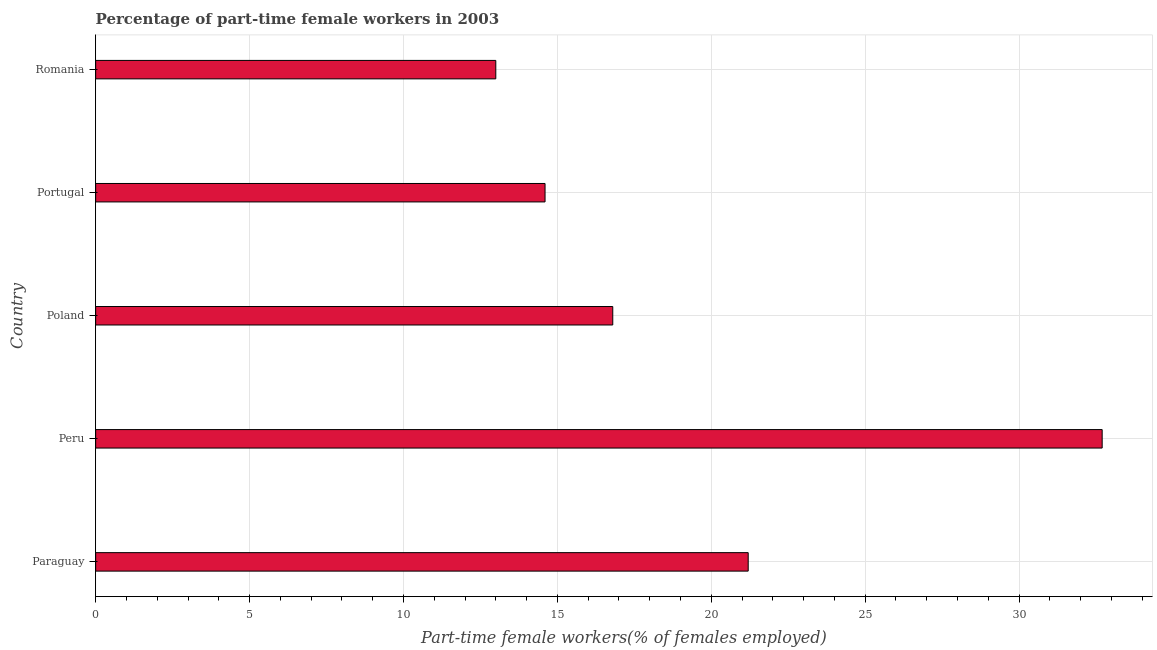Does the graph contain any zero values?
Offer a terse response. No. Does the graph contain grids?
Provide a short and direct response. Yes. What is the title of the graph?
Give a very brief answer. Percentage of part-time female workers in 2003. What is the label or title of the X-axis?
Provide a short and direct response. Part-time female workers(% of females employed). What is the label or title of the Y-axis?
Provide a short and direct response. Country. What is the percentage of part-time female workers in Poland?
Your answer should be compact. 16.8. Across all countries, what is the maximum percentage of part-time female workers?
Provide a short and direct response. 32.7. In which country was the percentage of part-time female workers minimum?
Provide a short and direct response. Romania. What is the sum of the percentage of part-time female workers?
Offer a very short reply. 98.3. What is the difference between the percentage of part-time female workers in Peru and Portugal?
Offer a terse response. 18.1. What is the average percentage of part-time female workers per country?
Offer a terse response. 19.66. What is the median percentage of part-time female workers?
Your response must be concise. 16.8. In how many countries, is the percentage of part-time female workers greater than 22 %?
Keep it short and to the point. 1. What is the ratio of the percentage of part-time female workers in Peru to that in Romania?
Provide a succinct answer. 2.52. Is the percentage of part-time female workers in Paraguay less than that in Portugal?
Offer a terse response. No. Is the difference between the percentage of part-time female workers in Paraguay and Poland greater than the difference between any two countries?
Make the answer very short. No. In how many countries, is the percentage of part-time female workers greater than the average percentage of part-time female workers taken over all countries?
Your answer should be compact. 2. What is the Part-time female workers(% of females employed) in Paraguay?
Offer a terse response. 21.2. What is the Part-time female workers(% of females employed) in Peru?
Provide a succinct answer. 32.7. What is the Part-time female workers(% of females employed) of Poland?
Ensure brevity in your answer.  16.8. What is the Part-time female workers(% of females employed) in Portugal?
Give a very brief answer. 14.6. What is the difference between the Part-time female workers(% of females employed) in Paraguay and Peru?
Make the answer very short. -11.5. What is the difference between the Part-time female workers(% of females employed) in Paraguay and Poland?
Give a very brief answer. 4.4. What is the difference between the Part-time female workers(% of females employed) in Paraguay and Romania?
Provide a succinct answer. 8.2. What is the difference between the Part-time female workers(% of females employed) in Peru and Poland?
Offer a very short reply. 15.9. What is the difference between the Part-time female workers(% of females employed) in Peru and Portugal?
Ensure brevity in your answer.  18.1. What is the difference between the Part-time female workers(% of females employed) in Poland and Romania?
Your response must be concise. 3.8. What is the ratio of the Part-time female workers(% of females employed) in Paraguay to that in Peru?
Keep it short and to the point. 0.65. What is the ratio of the Part-time female workers(% of females employed) in Paraguay to that in Poland?
Your answer should be very brief. 1.26. What is the ratio of the Part-time female workers(% of females employed) in Paraguay to that in Portugal?
Your answer should be very brief. 1.45. What is the ratio of the Part-time female workers(% of females employed) in Paraguay to that in Romania?
Ensure brevity in your answer.  1.63. What is the ratio of the Part-time female workers(% of females employed) in Peru to that in Poland?
Offer a very short reply. 1.95. What is the ratio of the Part-time female workers(% of females employed) in Peru to that in Portugal?
Provide a short and direct response. 2.24. What is the ratio of the Part-time female workers(% of females employed) in Peru to that in Romania?
Your answer should be compact. 2.52. What is the ratio of the Part-time female workers(% of females employed) in Poland to that in Portugal?
Your answer should be compact. 1.15. What is the ratio of the Part-time female workers(% of females employed) in Poland to that in Romania?
Provide a short and direct response. 1.29. What is the ratio of the Part-time female workers(% of females employed) in Portugal to that in Romania?
Give a very brief answer. 1.12. 